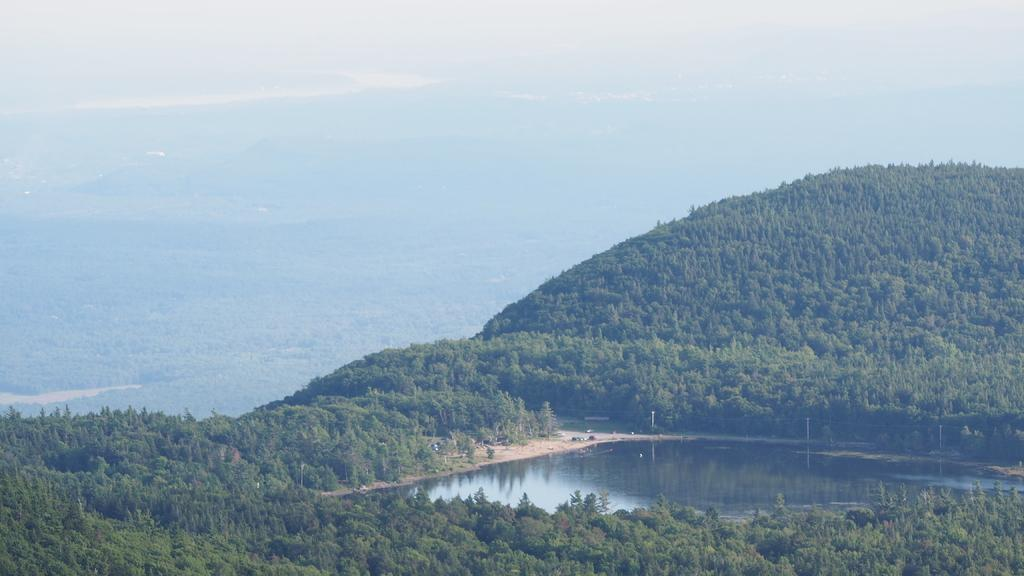What type of natural environment is depicted in the image? The image features many trees, indicating a forest or wooded area. What body of water can be seen in the image? There is water visible in the image. What is the condition of the sky in the background? The sky appears cloudy in the background. What type of coat is hanging on the tree in the image? There is no coat present in the image; it features trees, water, and a cloudy sky. What kind of soap is floating in the water in the image? There is no soap present in the image; it features trees, water, and a cloudy sky. 